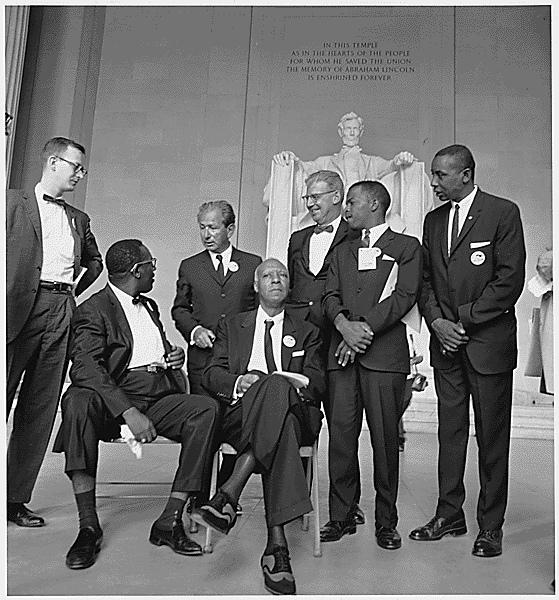Are all the men wearing glasses?
Write a very short answer. No. How many men are in this picture?
Keep it brief. 7. How are the men dressed?
Concise answer only. Formal. 